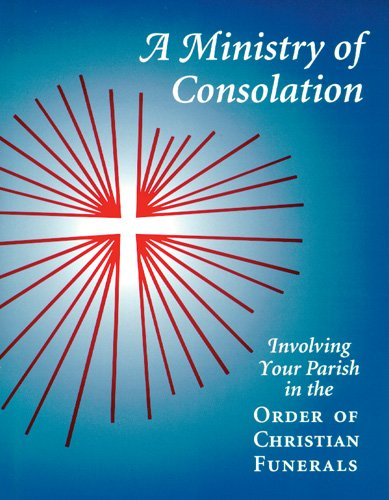Can you tell me more about the significance of the imagery on the book cover? The cover features a radiant cross, symbolizing hope and the Christian faith, which is central to the themes of consolation and mourning addressed in the book. 